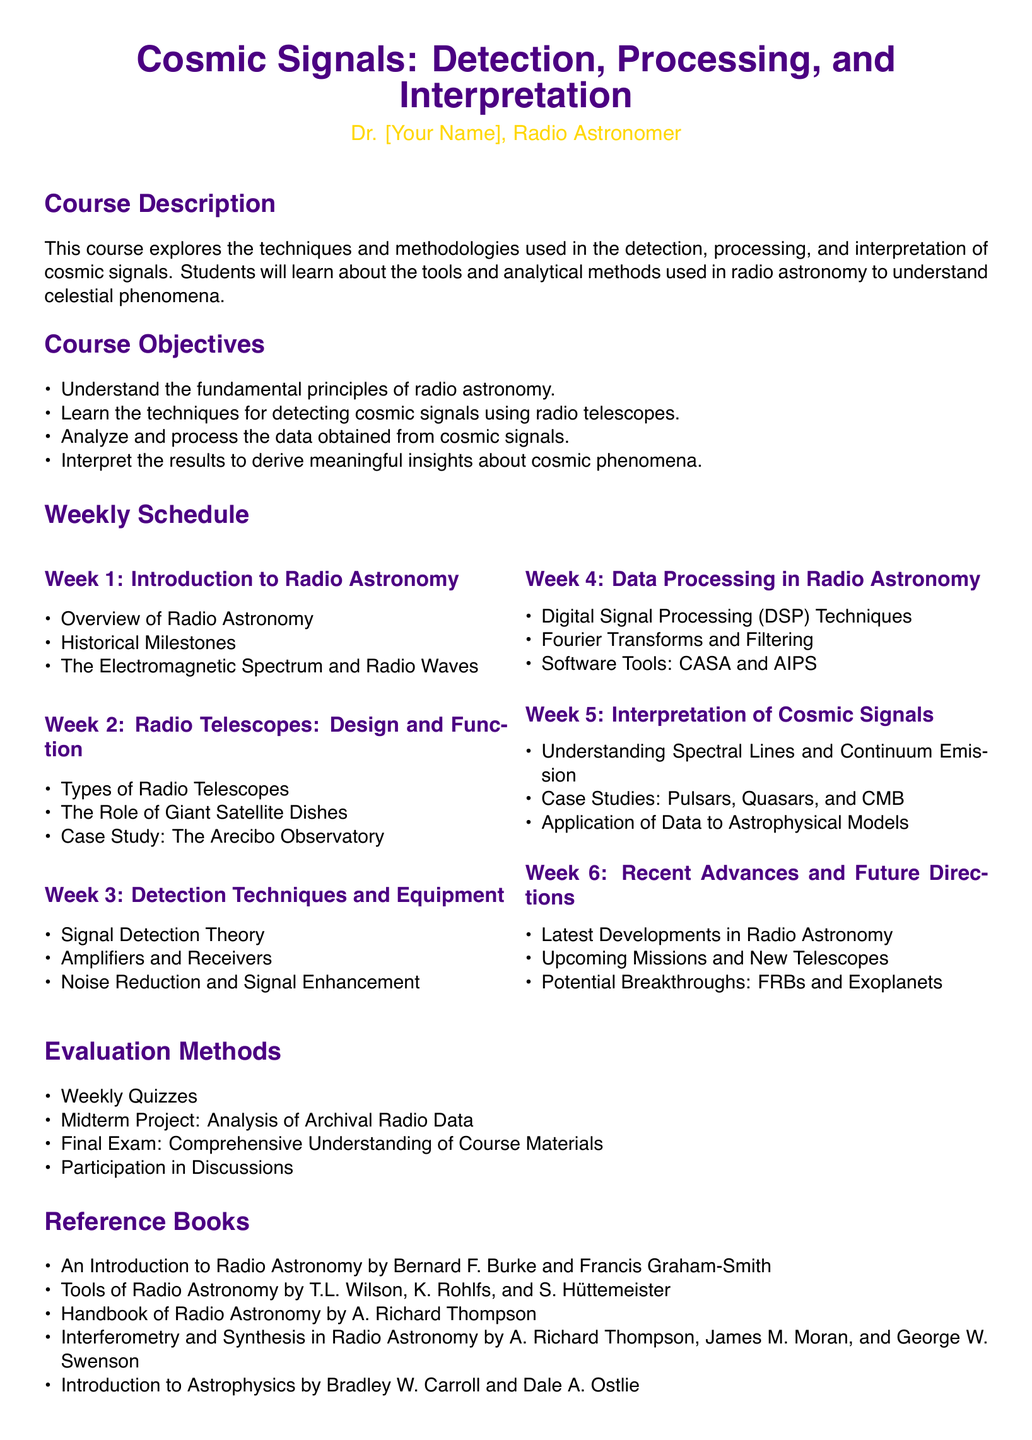What is the title of the course? The title of the course is provided at the beginning of the document.
Answer: Cosmic Signals: Detection, Processing, and Interpretation Who is the instructor for the course? The instructor's name is mentioned in the header section of the document.
Answer: Dr. [Your Name] What are the two types of radio telescopes mentioned? Types of radio telescopes are specified in Week 2: Radio Telescopes: Design and Function.
Answer: Types of Radio Telescopes What is the main focus of Week 5 in the syllabus? The syllabus outlines the primary topics covered each week; Week 5 deals with interpreting cosmic signals.
Answer: Interpretation of Cosmic Signals What is one of the evaluation methods for the course? The evaluation methods list various ways students will be assessed throughout the course.
Answer: Weekly Quizzes Which case study is included in the course content? Specific examples from the course are highlighted under Interpretation of Cosmic Signals.
Answer: Pulsars, Quasars, and CMB How many weeks does the course cover? The weekly schedule indicates the number of weeks outlined in the course syllabus.
Answer: Six weeks What type of signal processing techniques are covered in Week 4? This question pertains to the specific techniques mentioned for data processing in radio astronomy.
Answer: Digital Signal Processing Techniques 